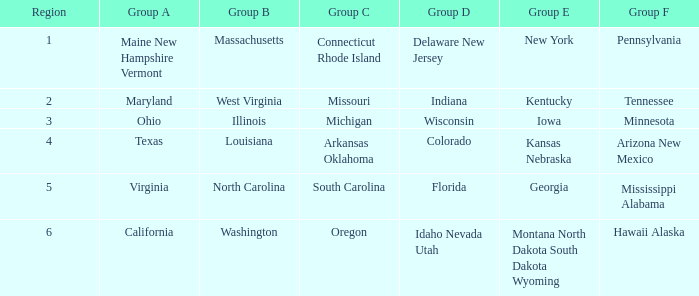In group a, what is the region that has the number 2 assigned to it? Maryland. Could you help me parse every detail presented in this table? {'header': ['Region', 'Group A', 'Group B', 'Group C', 'Group D', 'Group E', 'Group F'], 'rows': [['1', 'Maine New Hampshire Vermont', 'Massachusetts', 'Connecticut Rhode Island', 'Delaware New Jersey', 'New York', 'Pennsylvania'], ['2', 'Maryland', 'West Virginia', 'Missouri', 'Indiana', 'Kentucky', 'Tennessee'], ['3', 'Ohio', 'Illinois', 'Michigan', 'Wisconsin', 'Iowa', 'Minnesota'], ['4', 'Texas', 'Louisiana', 'Arkansas Oklahoma', 'Colorado', 'Kansas Nebraska', 'Arizona New Mexico'], ['5', 'Virginia', 'North Carolina', 'South Carolina', 'Florida', 'Georgia', 'Mississippi Alabama'], ['6', 'California', 'Washington', 'Oregon', 'Idaho Nevada Utah', 'Montana North Dakota South Dakota Wyoming', 'Hawaii Alaska']]} 